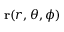<formula> <loc_0><loc_0><loc_500><loc_500>r ( r , \theta , \phi )</formula> 